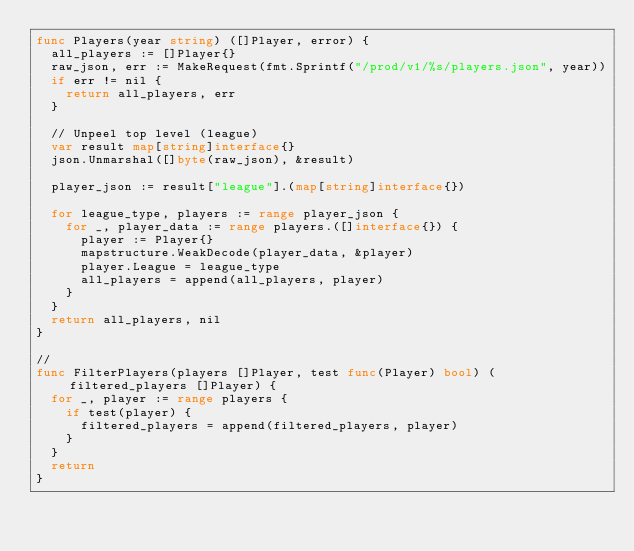Convert code to text. <code><loc_0><loc_0><loc_500><loc_500><_Go_>func Players(year string) ([]Player, error) {
	all_players := []Player{}
	raw_json, err := MakeRequest(fmt.Sprintf("/prod/v1/%s/players.json", year))
	if err != nil {
		return all_players, err
	}

	// Unpeel top level (league)
	var result map[string]interface{}
	json.Unmarshal([]byte(raw_json), &result)

	player_json := result["league"].(map[string]interface{})

	for league_type, players := range player_json {
		for _, player_data := range players.([]interface{}) {
			player := Player{}
			mapstructure.WeakDecode(player_data, &player)
			player.League = league_type
			all_players = append(all_players, player)
		}
	}
	return all_players, nil
}

//
func FilterPlayers(players []Player, test func(Player) bool) (filtered_players []Player) {
	for _, player := range players {
		if test(player) {
			filtered_players = append(filtered_players, player)
		}
	}
	return
}
</code> 